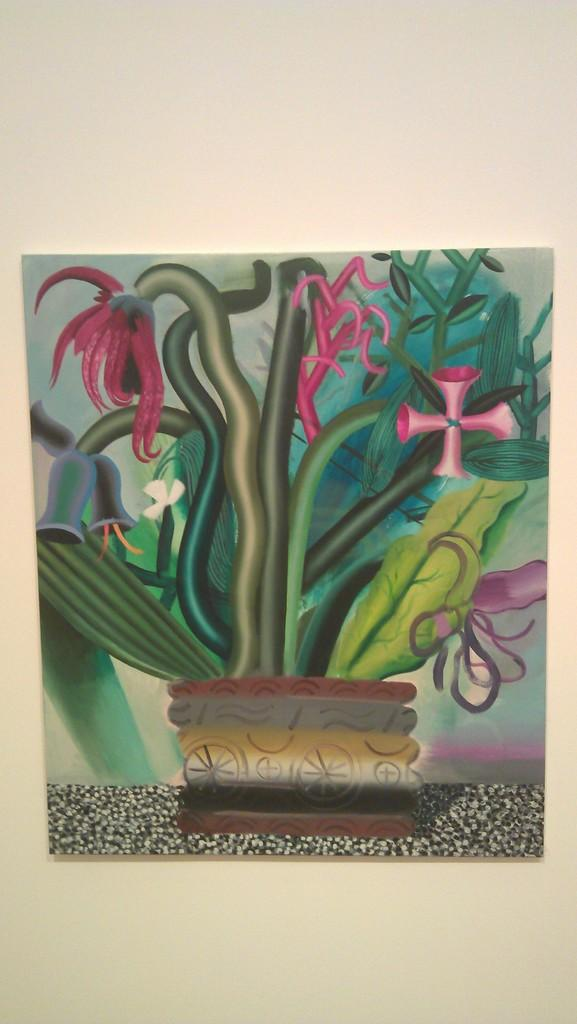What is the main subject of the painting in the image? The painting depicts a flower pot. Where is the painting located in the image? The painting is on the surface of rocks. What material is the painting on? The painting is on paper. How is the paper with the painting attached in the image? The paper is attached to a wall. How many volleyballs are visible in the image? There are no volleyballs present in the image. What type of clocks are featured in the painting? The painting depicts a flower pot, not clocks. Is there a coach in the image? There is no coach present in the image. 